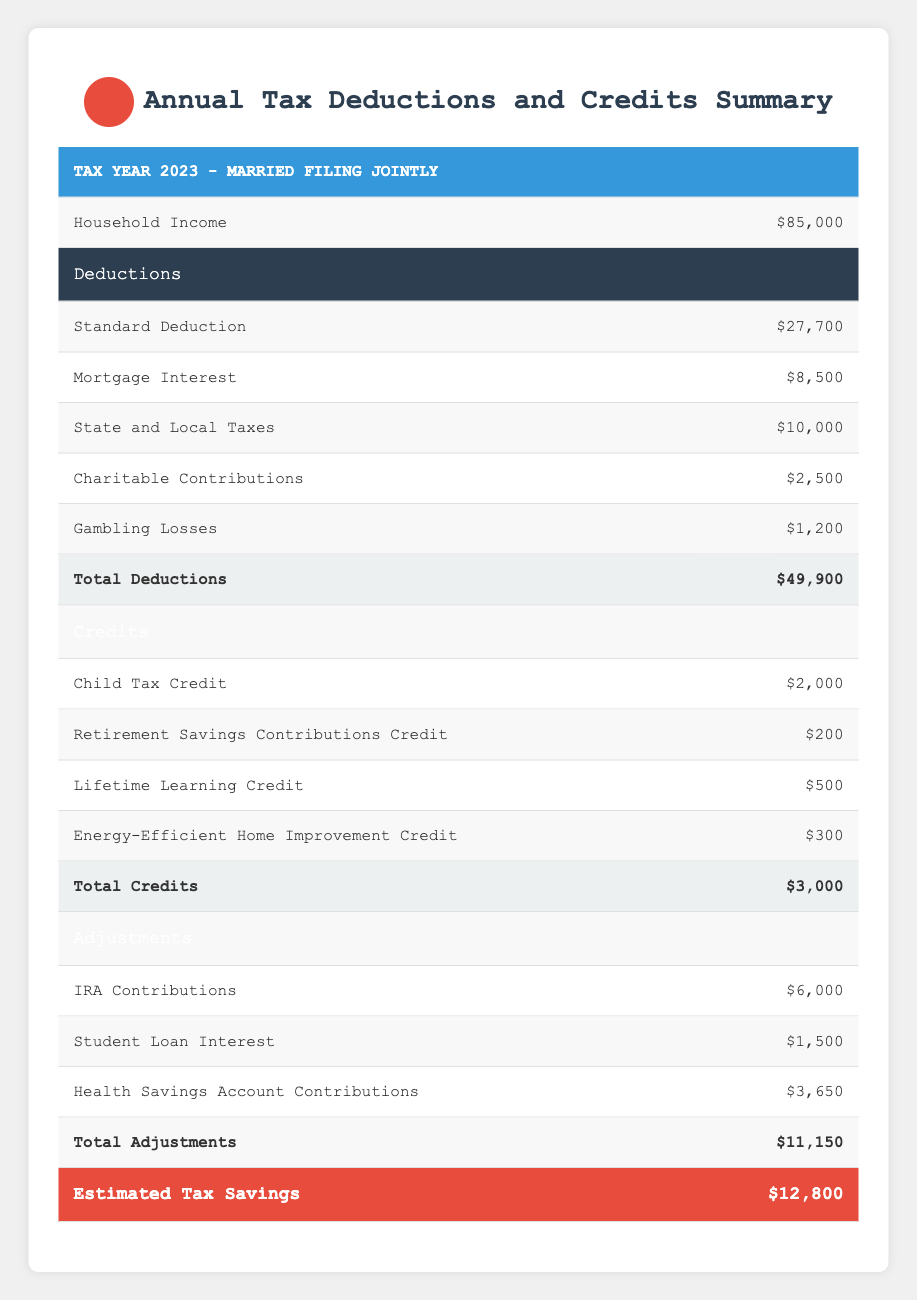What is the total amount of standard deduction for 2023? The table specifies the amount of the standard deduction as $27,700 for the year 2023.
Answer: 27,700 What is the total of the mortgage interest deduction? According to the table, the mortgage interest deduction is $8,500.
Answer: 8,500 True or False: The total deductions exceed the household income. The total deductions are $49,900, which is higher than the household income of $85,000 indicating the statement is false.
Answer: False How much did the household contribute to their Health Savings Account? The table states the contributions to the Health Savings Account are $3,650.
Answer: 3,650 What is the total tax savings estimated for this household? The estimated tax savings shown in the table is $12,800.
Answer: 12,800 What is the combined amount of the Child Tax Credit and the Lifetime Learning Credit? The Child Tax Credit is $2,000 and the Lifetime Learning Credit is $500. Adding these amounts gives $2,000 + $500 = $2,500.
Answer: 2,500 How does the total credits compare to the total deductions? The total credits amount to $3,000 while total deductions are $49,900. Since $3,000 is less than $49,900, the total credits are much lower than total deductions.
Answer: Total credits are less than total deductions What is the net deduction amount after applying the total adjustments? The total deductions are $49,900 and the total adjustments are $11,150. We subtract the adjustments from the deductions: $49,900 - $11,150 = $38,750 for the net deduction amount.
Answer: 38,750 Is the amount for State and Local Taxes greater than the amount for Charitable Contributions? The table shows State and Local Taxes at $10,000 and Charitable Contributions at $2,500. Since $10,000 is greater than $2,500, the statement is true.
Answer: True 